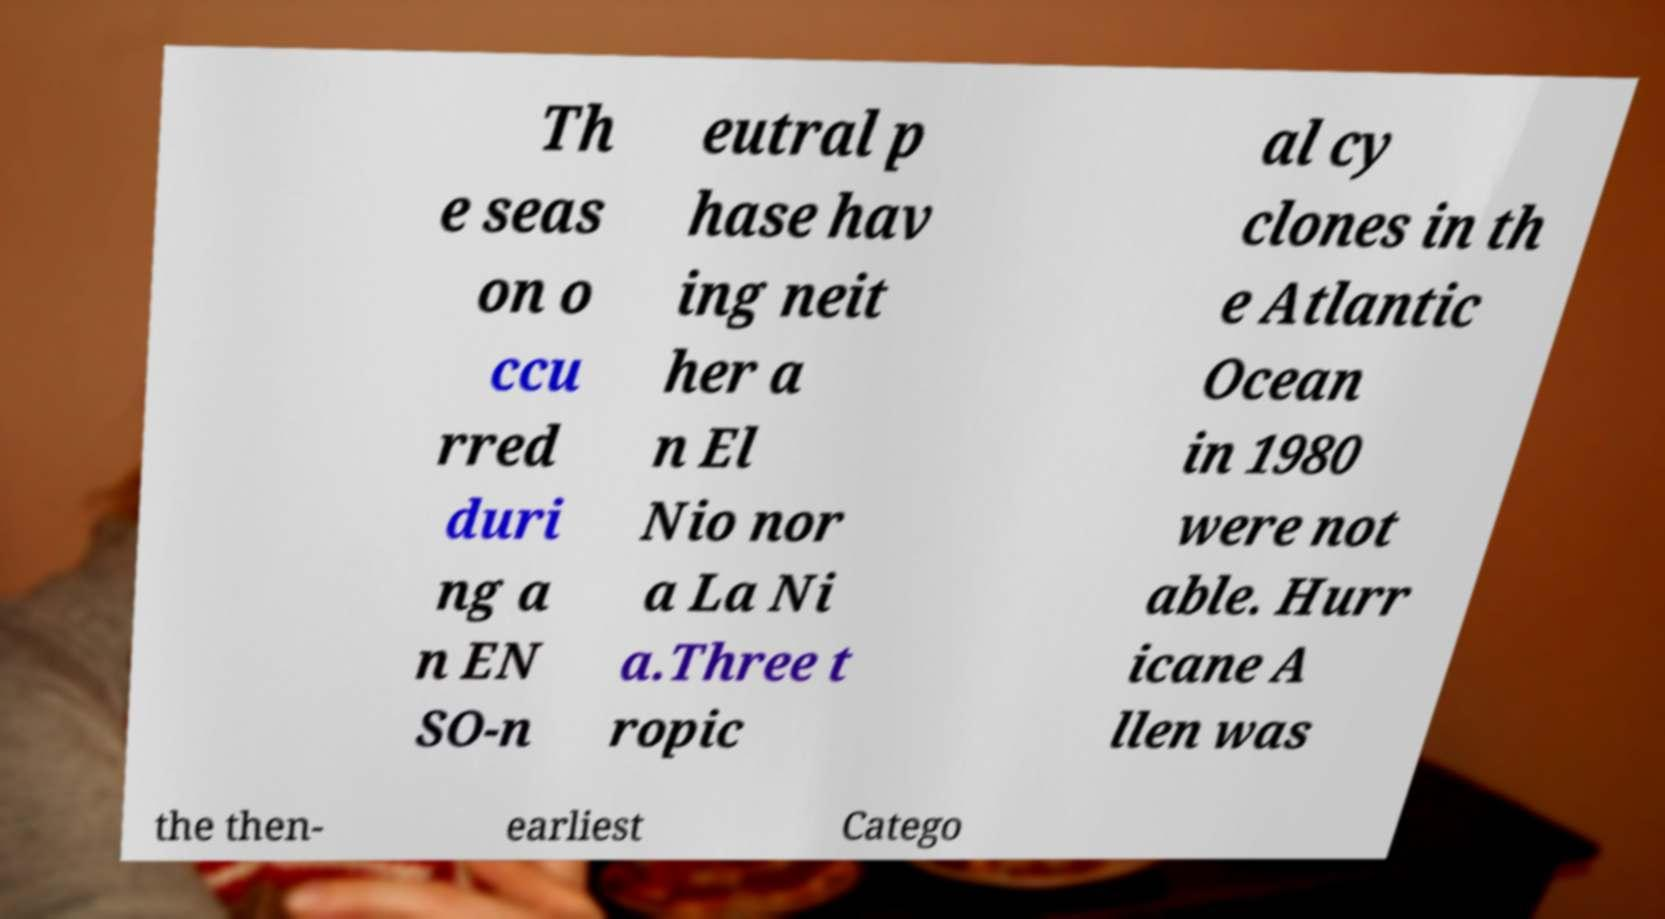Please read and relay the text visible in this image. What does it say? Th e seas on o ccu rred duri ng a n EN SO-n eutral p hase hav ing neit her a n El Nio nor a La Ni a.Three t ropic al cy clones in th e Atlantic Ocean in 1980 were not able. Hurr icane A llen was the then- earliest Catego 